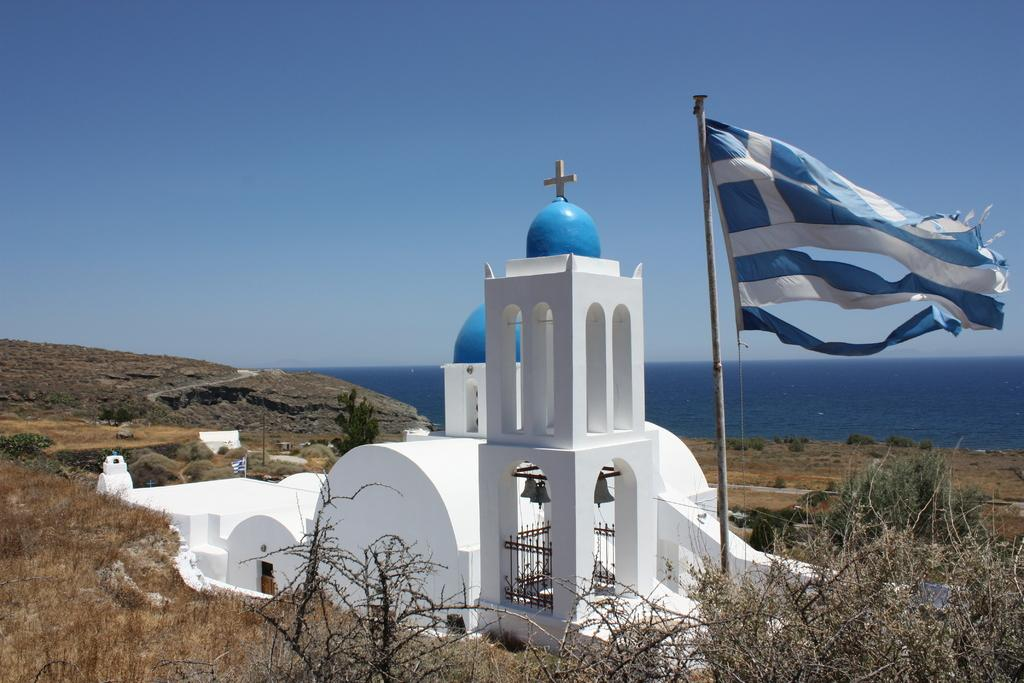What type of building is in the image? There is a chapel in the image. What type of vegetation is present in the image? There are trees in the image. What structure is used to display a flag in the image? There is a flag pole in the image. What natural element is visible in the image? Water is visible in the image. How would you describe the sky in the image? The sky is blue and cloudy in the image. What type of ground cover is present in the image? There is grass on the ground in the image. What memory does the grandfather share with the family in the image? There is no reference to a grandfather or any memories being shared in the image. What type of drug is being administered to the person in the image? There is no person or drug present in the image. 